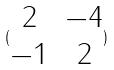Convert formula to latex. <formula><loc_0><loc_0><loc_500><loc_500>( \begin{matrix} 2 & - 4 \\ - 1 & 2 \end{matrix} )</formula> 